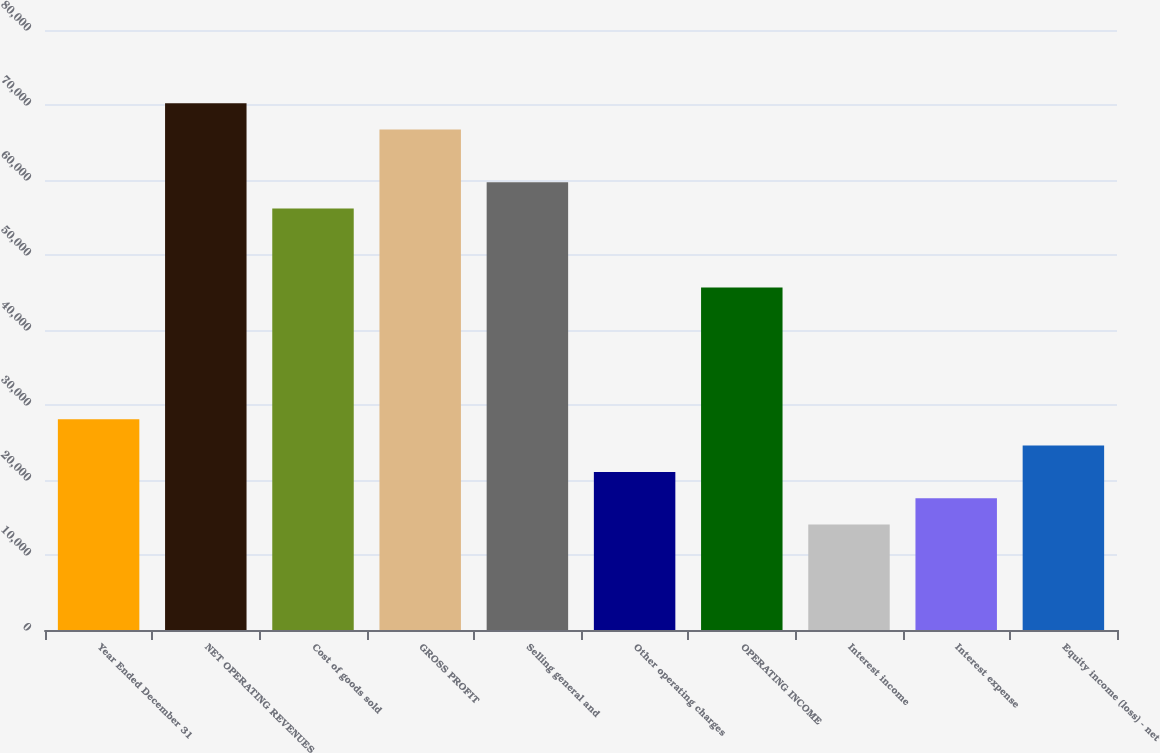Convert chart to OTSL. <chart><loc_0><loc_0><loc_500><loc_500><bar_chart><fcel>Year Ended December 31<fcel>NET OPERATING REVENUES<fcel>Cost of goods sold<fcel>GROSS PROFIT<fcel>Selling general and<fcel>Other operating charges<fcel>OPERATING INCOME<fcel>Interest income<fcel>Interest expense<fcel>Equity income (loss) - net<nl><fcel>28096.2<fcel>70232.9<fcel>56187.3<fcel>66721.5<fcel>59698.7<fcel>21073.4<fcel>45653.1<fcel>14050.6<fcel>17562<fcel>24584.8<nl></chart> 